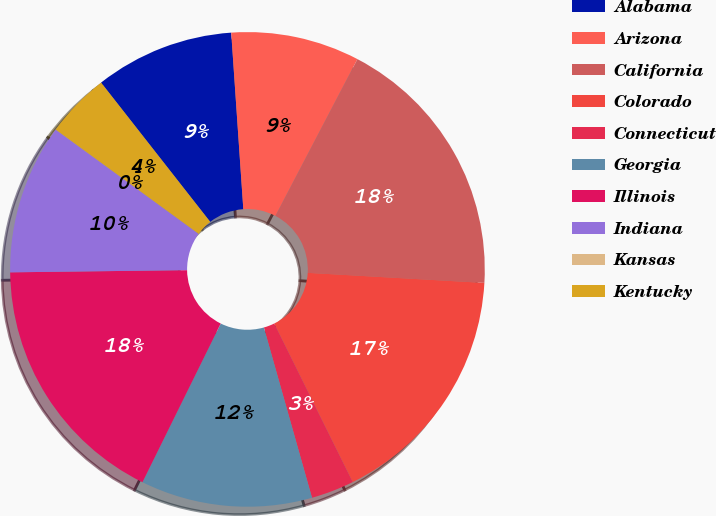Convert chart. <chart><loc_0><loc_0><loc_500><loc_500><pie_chart><fcel>Alabama<fcel>Arizona<fcel>California<fcel>Colorado<fcel>Connecticut<fcel>Georgia<fcel>Illinois<fcel>Indiana<fcel>Kansas<fcel>Kentucky<nl><fcel>9.49%<fcel>8.76%<fcel>18.24%<fcel>16.78%<fcel>2.93%<fcel>11.68%<fcel>17.51%<fcel>10.22%<fcel>0.01%<fcel>4.39%<nl></chart> 